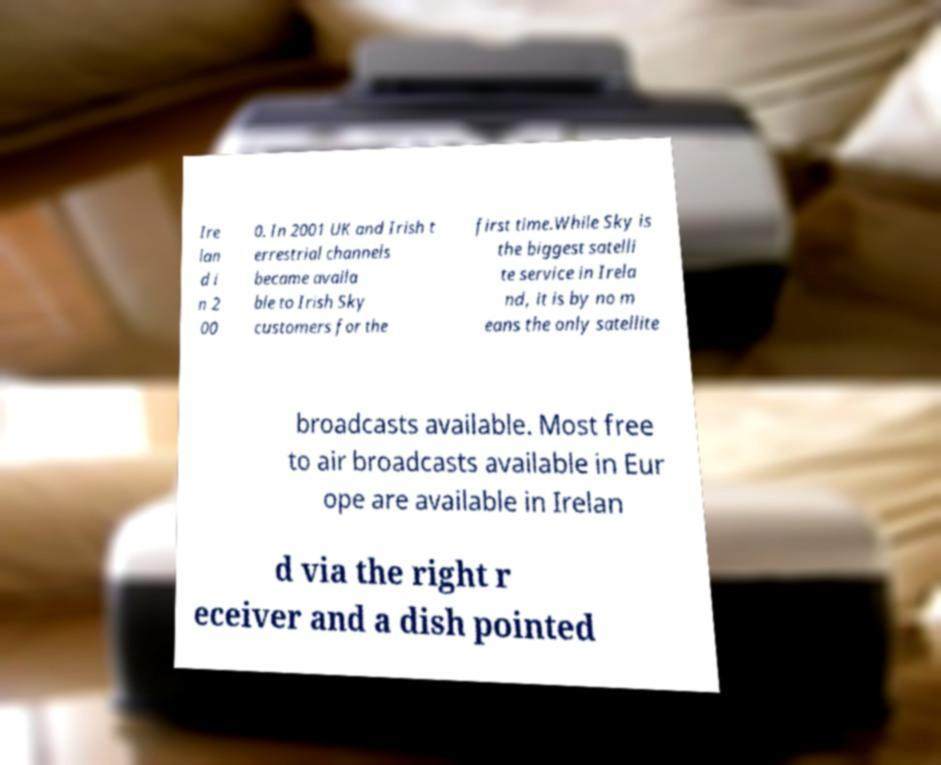Could you assist in decoding the text presented in this image and type it out clearly? Ire lan d i n 2 00 0. In 2001 UK and Irish t errestrial channels became availa ble to Irish Sky customers for the first time.While Sky is the biggest satelli te service in Irela nd, it is by no m eans the only satellite broadcasts available. Most free to air broadcasts available in Eur ope are available in Irelan d via the right r eceiver and a dish pointed 